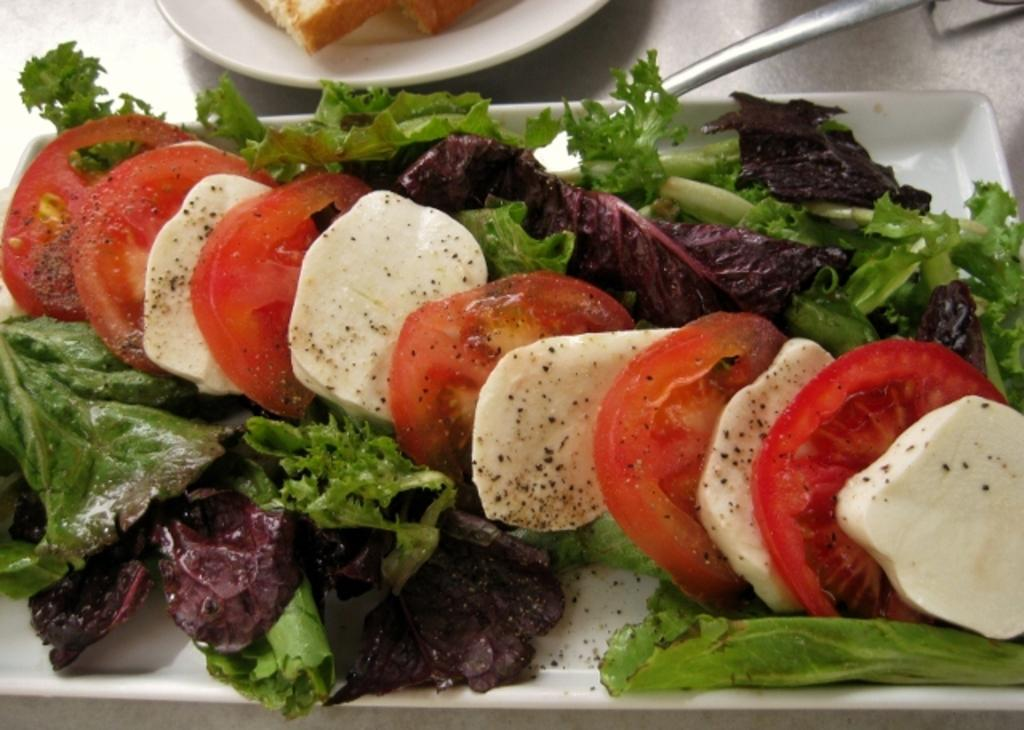What type of food is in the plate that is visible in the image? There is a salad in a plate in the image. Can you describe the other plate visible in the image? There is another plate visible at the top of the image, but no specific details about its contents are provided. What type of nerve is visible in the image? There is no nerve visible in the image. Can you describe the anger in the image? There is no anger depicted in the image. 